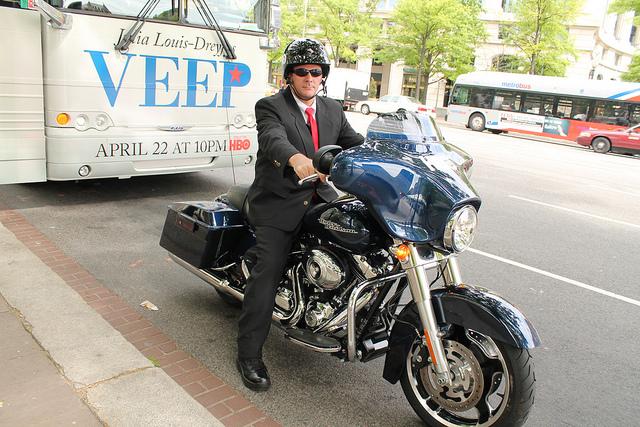What is the man wearing?
Be succinct. Suit. Who stars in the advertised movie?
Write a very short answer. Julia louis dreyfus. What date is being advertised?
Write a very short answer. April 22. 